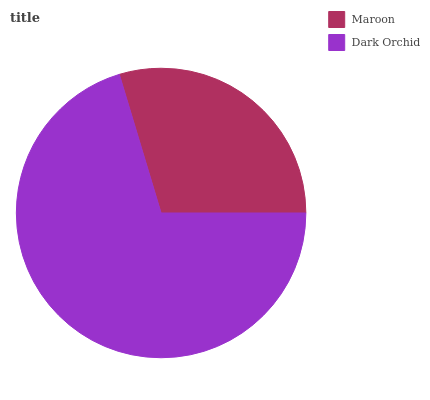Is Maroon the minimum?
Answer yes or no. Yes. Is Dark Orchid the maximum?
Answer yes or no. Yes. Is Dark Orchid the minimum?
Answer yes or no. No. Is Dark Orchid greater than Maroon?
Answer yes or no. Yes. Is Maroon less than Dark Orchid?
Answer yes or no. Yes. Is Maroon greater than Dark Orchid?
Answer yes or no. No. Is Dark Orchid less than Maroon?
Answer yes or no. No. Is Dark Orchid the high median?
Answer yes or no. Yes. Is Maroon the low median?
Answer yes or no. Yes. Is Maroon the high median?
Answer yes or no. No. Is Dark Orchid the low median?
Answer yes or no. No. 